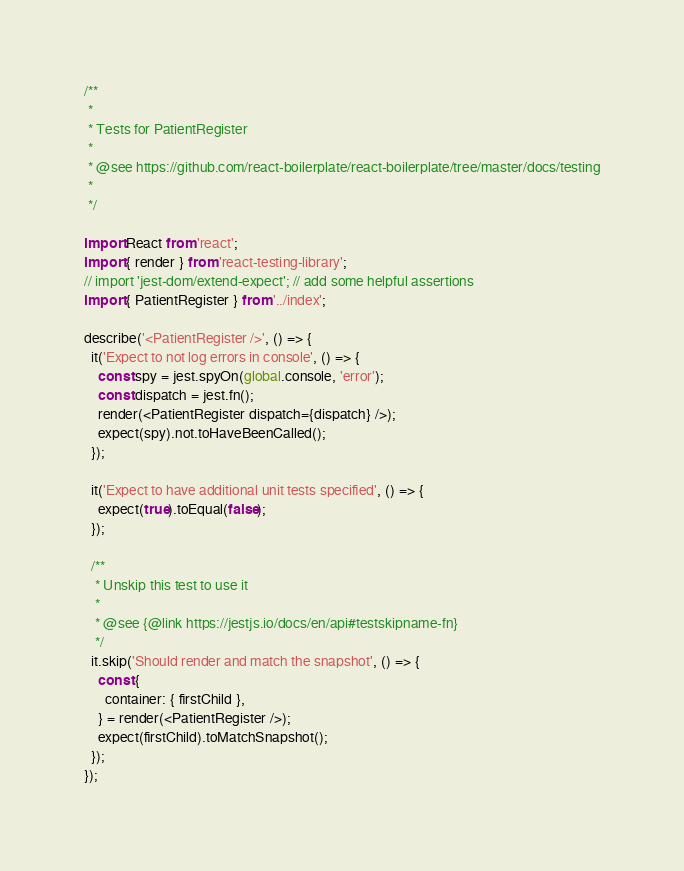Convert code to text. <code><loc_0><loc_0><loc_500><loc_500><_JavaScript_>/**
 *
 * Tests for PatientRegister
 *
 * @see https://github.com/react-boilerplate/react-boilerplate/tree/master/docs/testing
 *
 */

import React from 'react';
import { render } from 'react-testing-library';
// import 'jest-dom/extend-expect'; // add some helpful assertions
import { PatientRegister } from '../index';

describe('<PatientRegister />', () => {
  it('Expect to not log errors in console', () => {
    const spy = jest.spyOn(global.console, 'error');
    const dispatch = jest.fn();
    render(<PatientRegister dispatch={dispatch} />);
    expect(spy).not.toHaveBeenCalled();
  });

  it('Expect to have additional unit tests specified', () => {
    expect(true).toEqual(false);
  });

  /**
   * Unskip this test to use it
   *
   * @see {@link https://jestjs.io/docs/en/api#testskipname-fn}
   */
  it.skip('Should render and match the snapshot', () => {
    const {
      container: { firstChild },
    } = render(<PatientRegister />);
    expect(firstChild).toMatchSnapshot();
  });
});
</code> 